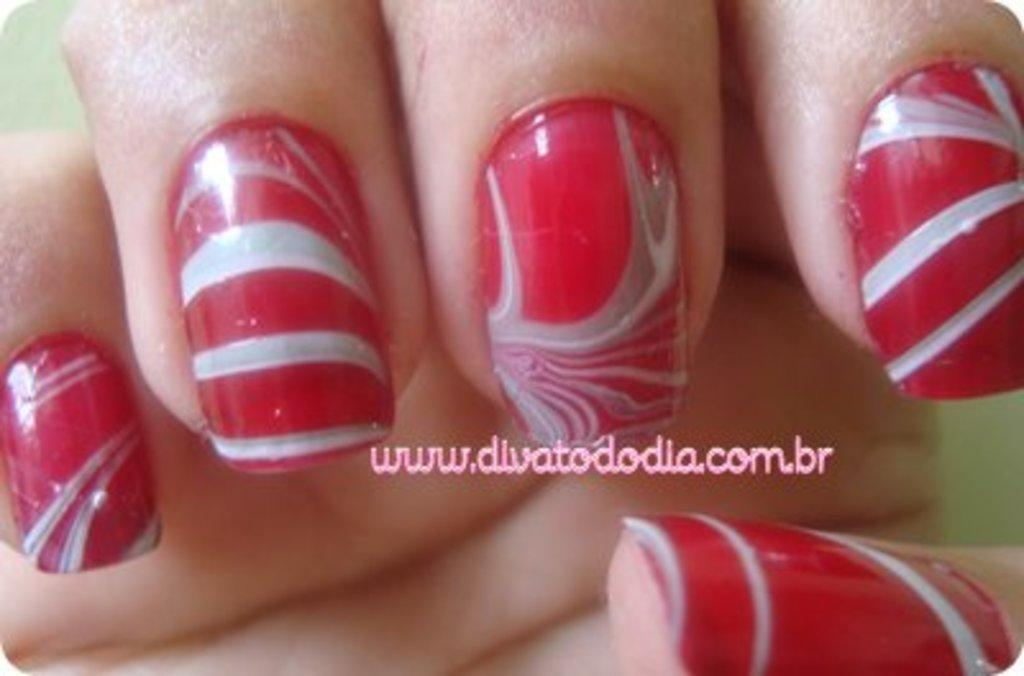<image>
Share a concise interpretation of the image provided. a womans nails that are painted and the website 'www.divatododia.com.br' written on the screen 